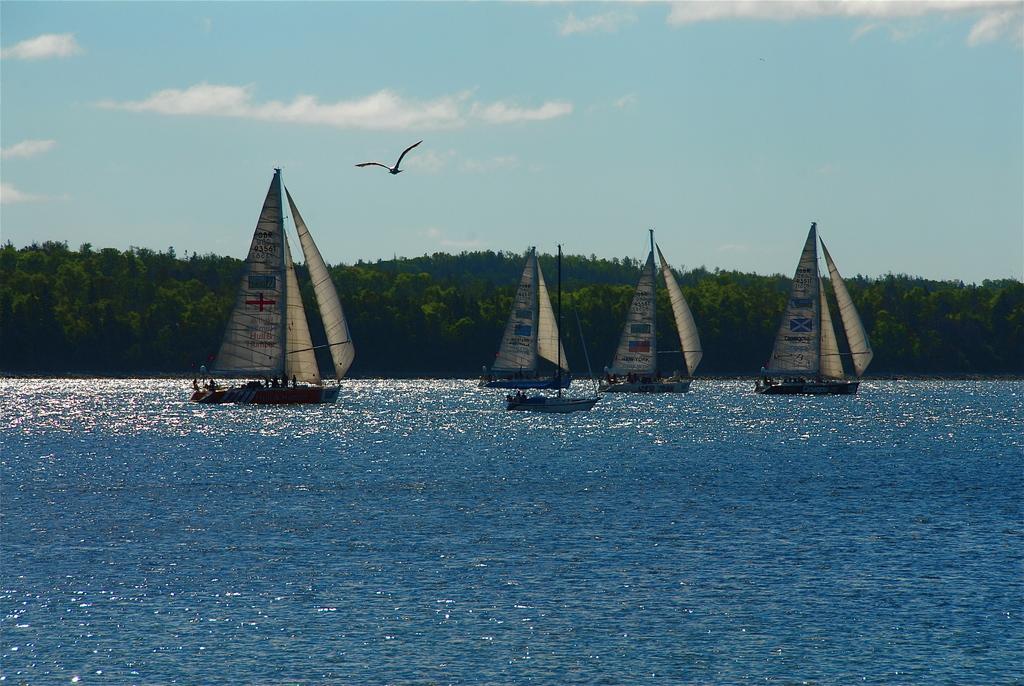How would you summarize this image in a sentence or two? There are some boats on the surface of water as we can see in the middle of this image. There are some trees in the background. There is a sky at the top of this image. We can see there is a bird at the top of this image. 